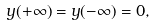Convert formula to latex. <formula><loc_0><loc_0><loc_500><loc_500>y ( + \infty ) = y ( - \infty ) = 0 ,</formula> 